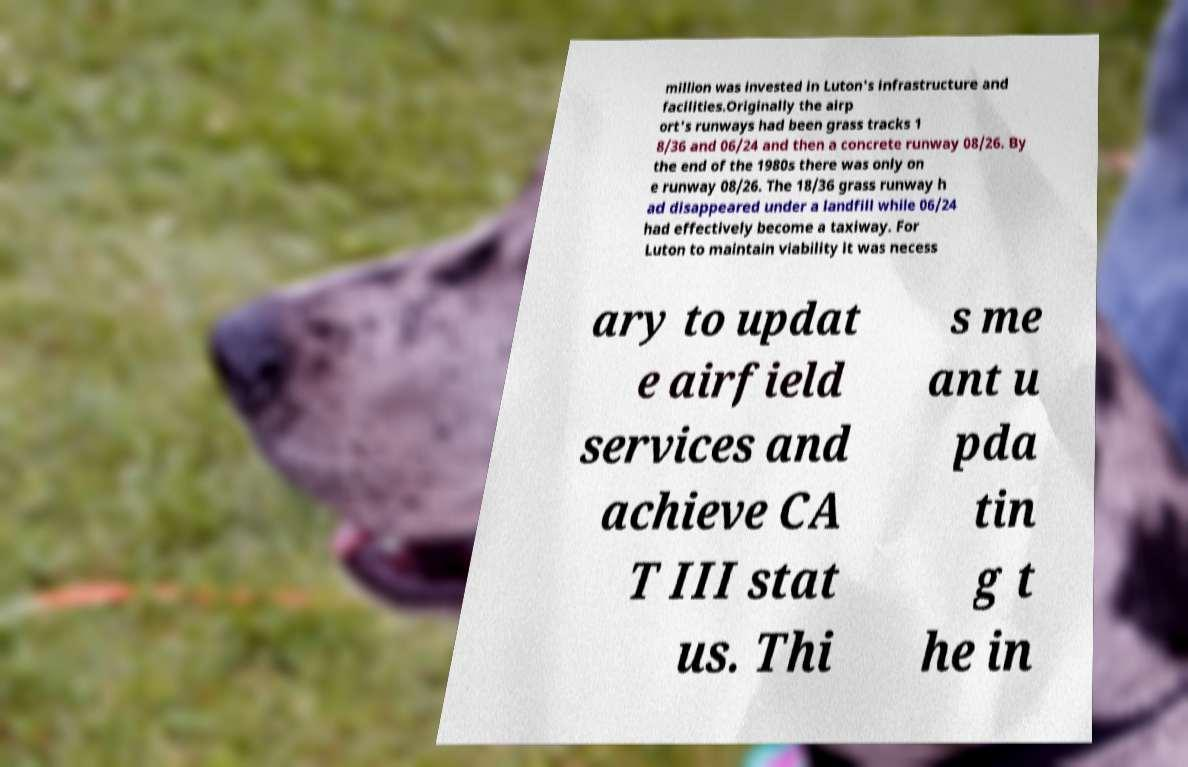For documentation purposes, I need the text within this image transcribed. Could you provide that? million was invested in Luton's infrastructure and facilities.Originally the airp ort's runways had been grass tracks 1 8/36 and 06/24 and then a concrete runway 08/26. By the end of the 1980s there was only on e runway 08/26. The 18/36 grass runway h ad disappeared under a landfill while 06/24 had effectively become a taxiway. For Luton to maintain viability it was necess ary to updat e airfield services and achieve CA T III stat us. Thi s me ant u pda tin g t he in 